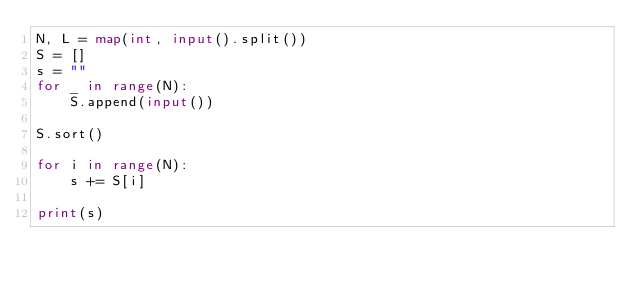<code> <loc_0><loc_0><loc_500><loc_500><_Python_>N, L = map(int, input().split())
S = []
s = ""
for _ in range(N):
    S.append(input())
    
S.sort()
    
for i in range(N):
    s += S[i]
    
print(s)
    </code> 